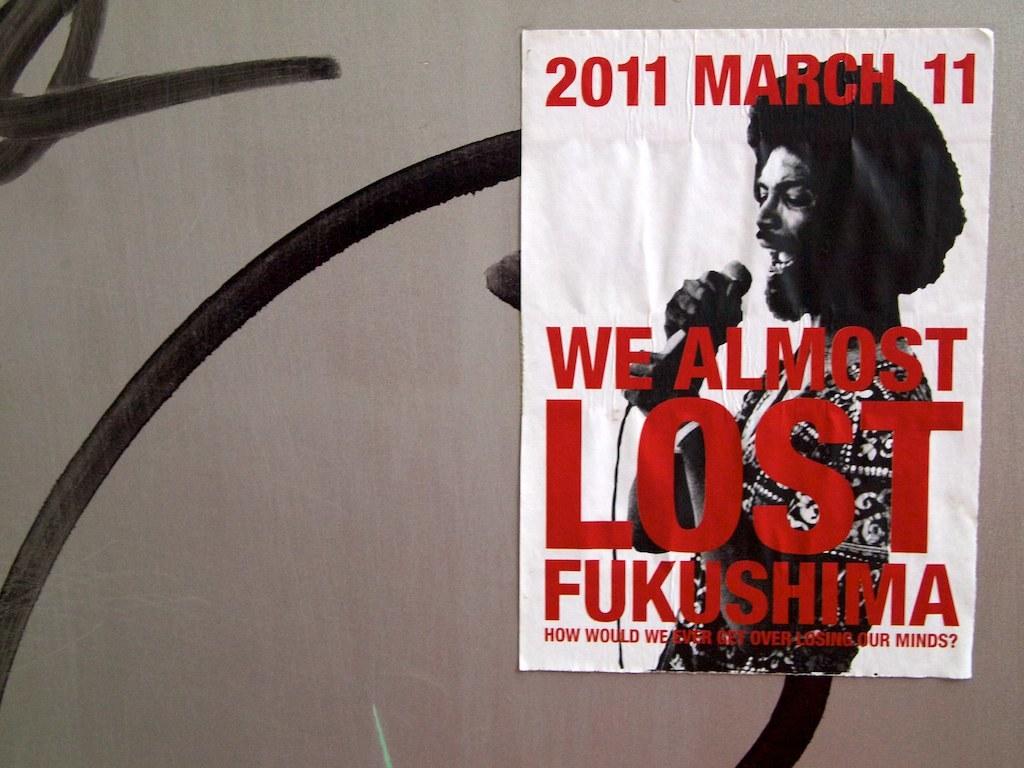What is the date on this poster?
Offer a very short reply. 2011 march 11. Who do we almost lose?
Provide a succinct answer. Fukushima. 